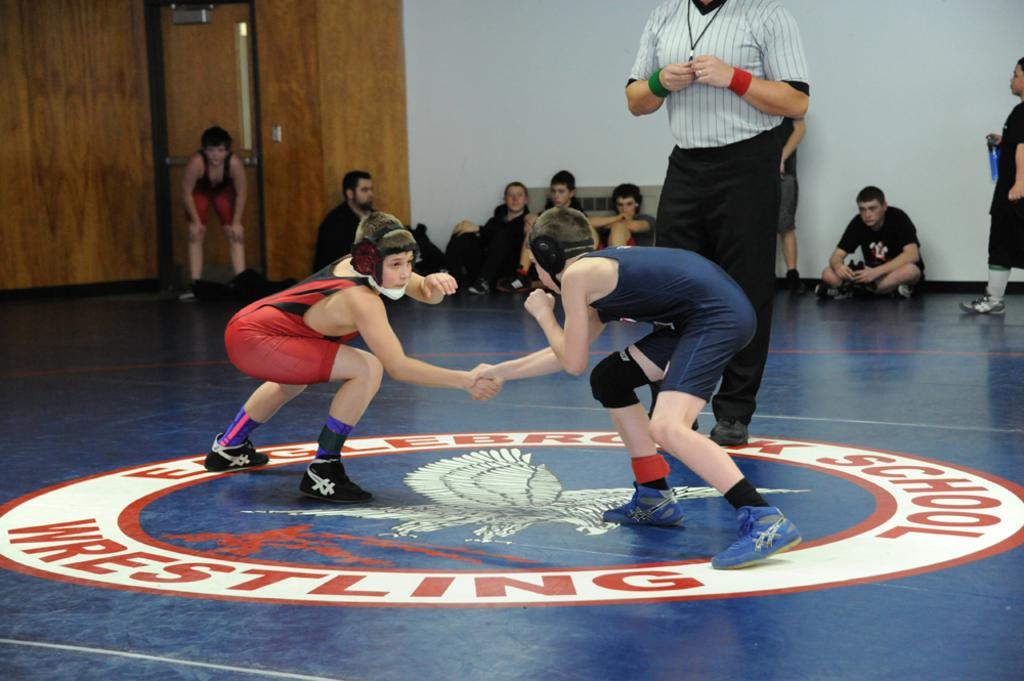Provide a one-sentence caption for the provided image. The red Englebrook Highschool Wrestling font is quite large but bold as well. 